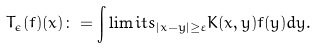<formula> <loc_0><loc_0><loc_500><loc_500>T _ { \epsilon } ( f ) ( x ) \colon = \int \lim i t s _ { | x - y | \geq \varepsilon } K ( x , y ) f ( y ) d y .</formula> 